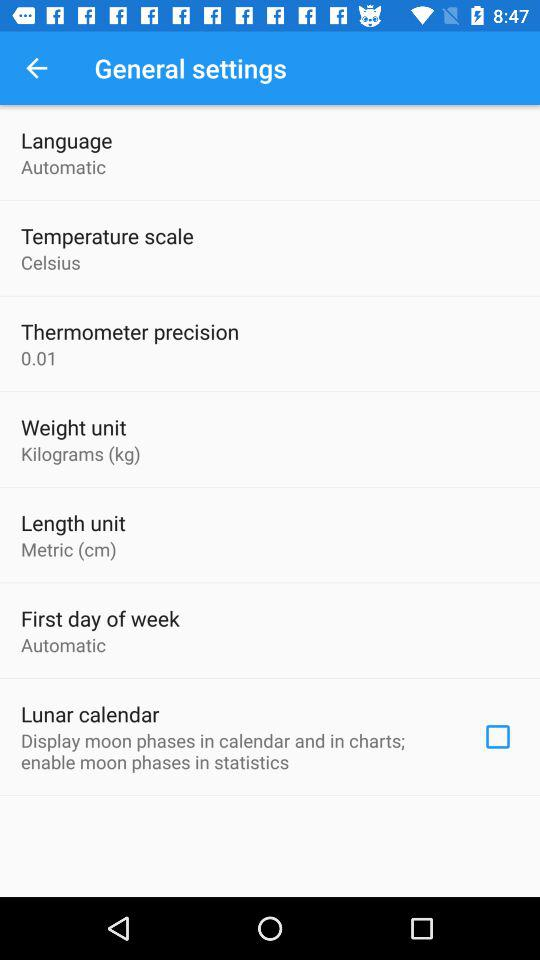For what setting is a metric (cm) unit selected? A metric (cm) unit is selected for length. 